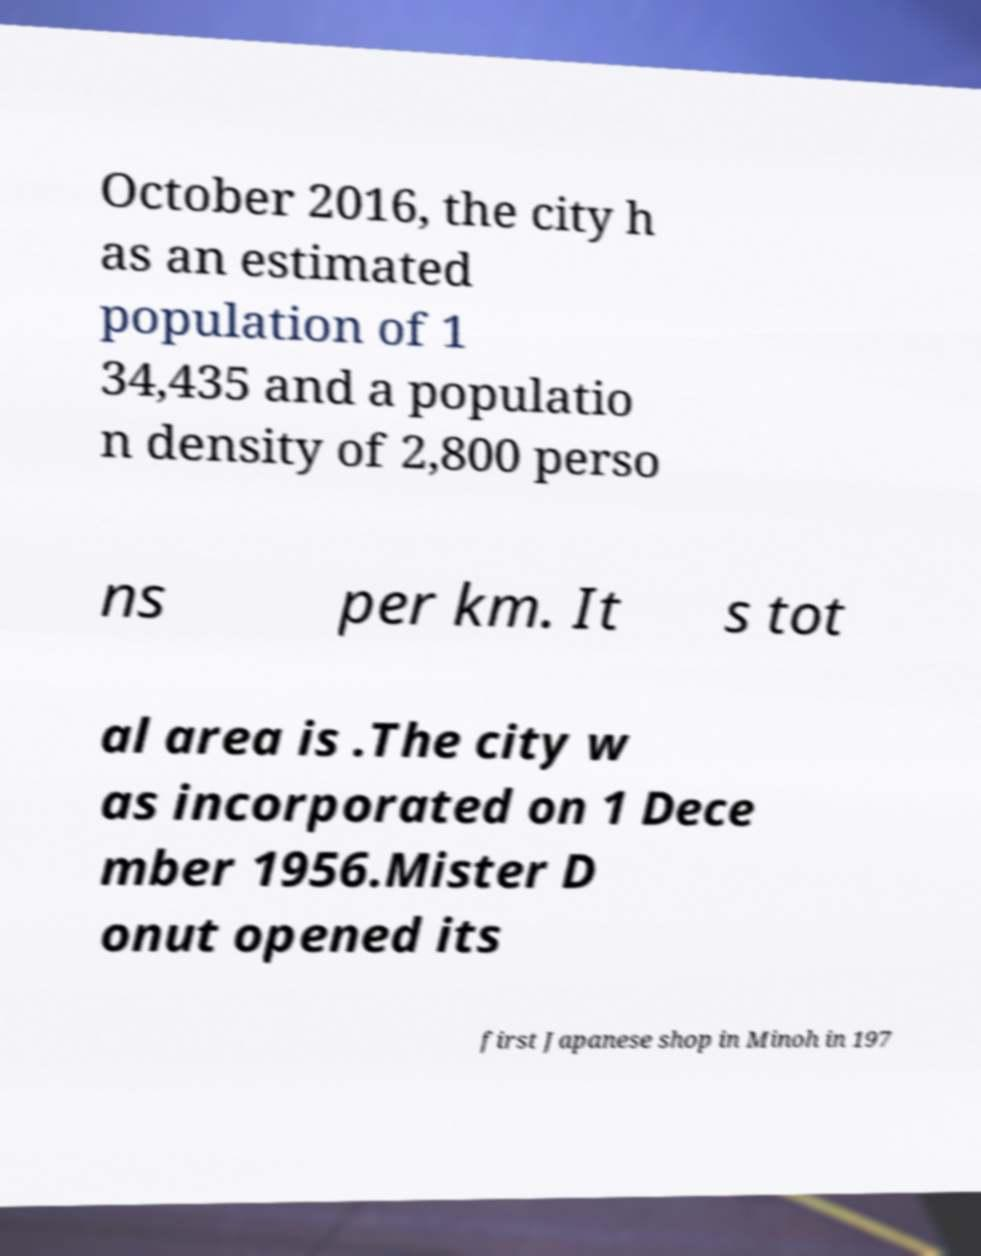Can you read and provide the text displayed in the image?This photo seems to have some interesting text. Can you extract and type it out for me? October 2016, the city h as an estimated population of 1 34,435 and a populatio n density of 2,800 perso ns per km. It s tot al area is .The city w as incorporated on 1 Dece mber 1956.Mister D onut opened its first Japanese shop in Minoh in 197 